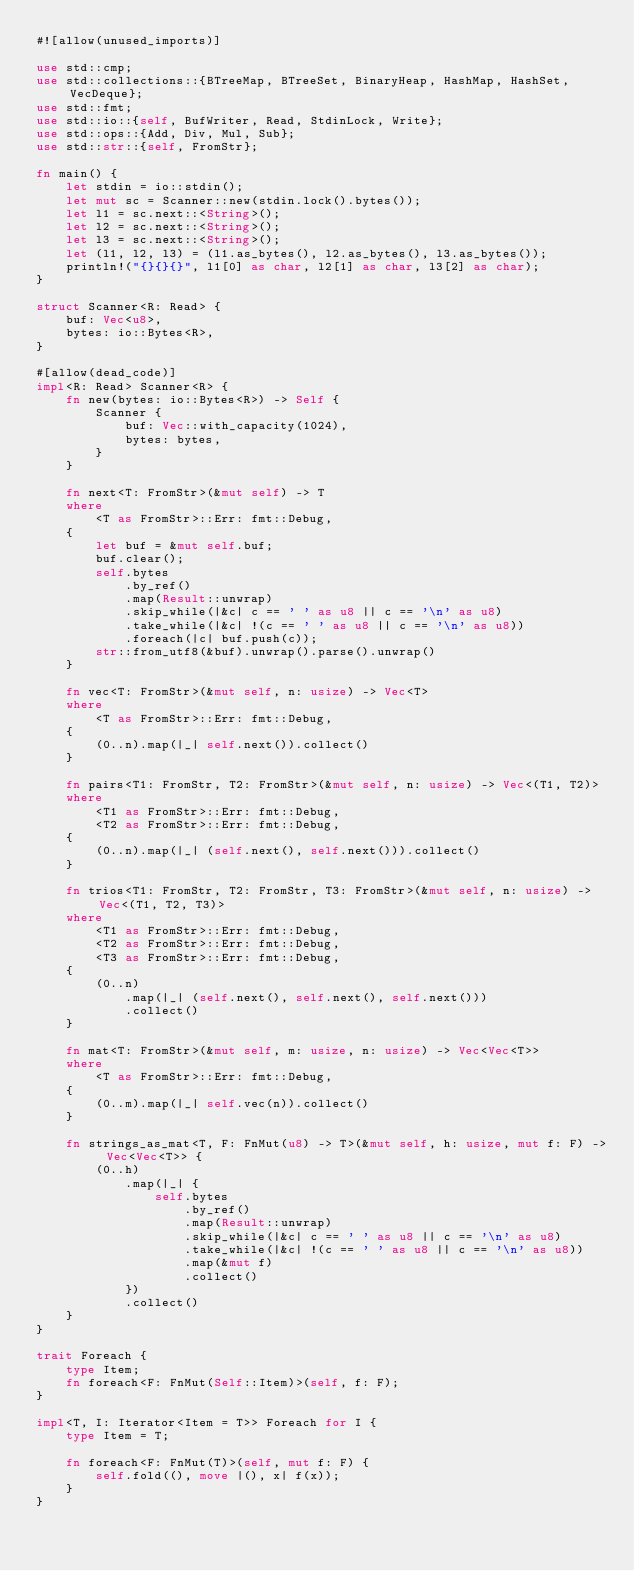Convert code to text. <code><loc_0><loc_0><loc_500><loc_500><_Rust_>#![allow(unused_imports)]

use std::cmp;
use std::collections::{BTreeMap, BTreeSet, BinaryHeap, HashMap, HashSet, VecDeque};
use std::fmt;
use std::io::{self, BufWriter, Read, StdinLock, Write};
use std::ops::{Add, Div, Mul, Sub};
use std::str::{self, FromStr};

fn main() {
    let stdin = io::stdin();
    let mut sc = Scanner::new(stdin.lock().bytes());
    let l1 = sc.next::<String>();
    let l2 = sc.next::<String>();
    let l3 = sc.next::<String>();
    let (l1, l2, l3) = (l1.as_bytes(), l2.as_bytes(), l3.as_bytes());
    println!("{}{}{}", l1[0] as char, l2[1] as char, l3[2] as char);
}

struct Scanner<R: Read> {
    buf: Vec<u8>,
    bytes: io::Bytes<R>,
}

#[allow(dead_code)]
impl<R: Read> Scanner<R> {
    fn new(bytes: io::Bytes<R>) -> Self {
        Scanner {
            buf: Vec::with_capacity(1024),
            bytes: bytes,
        }
    }

    fn next<T: FromStr>(&mut self) -> T
    where
        <T as FromStr>::Err: fmt::Debug,
    {
        let buf = &mut self.buf;
        buf.clear();
        self.bytes
            .by_ref()
            .map(Result::unwrap)
            .skip_while(|&c| c == ' ' as u8 || c == '\n' as u8)
            .take_while(|&c| !(c == ' ' as u8 || c == '\n' as u8))
            .foreach(|c| buf.push(c));
        str::from_utf8(&buf).unwrap().parse().unwrap()
    }

    fn vec<T: FromStr>(&mut self, n: usize) -> Vec<T>
    where
        <T as FromStr>::Err: fmt::Debug,
    {
        (0..n).map(|_| self.next()).collect()
    }

    fn pairs<T1: FromStr, T2: FromStr>(&mut self, n: usize) -> Vec<(T1, T2)>
    where
        <T1 as FromStr>::Err: fmt::Debug,
        <T2 as FromStr>::Err: fmt::Debug,
    {
        (0..n).map(|_| (self.next(), self.next())).collect()
    }

    fn trios<T1: FromStr, T2: FromStr, T3: FromStr>(&mut self, n: usize) -> Vec<(T1, T2, T3)>
    where
        <T1 as FromStr>::Err: fmt::Debug,
        <T2 as FromStr>::Err: fmt::Debug,
        <T3 as FromStr>::Err: fmt::Debug,
    {
        (0..n)
            .map(|_| (self.next(), self.next(), self.next()))
            .collect()
    }

    fn mat<T: FromStr>(&mut self, m: usize, n: usize) -> Vec<Vec<T>>
    where
        <T as FromStr>::Err: fmt::Debug,
    {
        (0..m).map(|_| self.vec(n)).collect()
    }

    fn strings_as_mat<T, F: FnMut(u8) -> T>(&mut self, h: usize, mut f: F) -> Vec<Vec<T>> {
        (0..h)
            .map(|_| {
                self.bytes
                    .by_ref()
                    .map(Result::unwrap)
                    .skip_while(|&c| c == ' ' as u8 || c == '\n' as u8)
                    .take_while(|&c| !(c == ' ' as u8 || c == '\n' as u8))
                    .map(&mut f)
                    .collect()
            })
            .collect()
    }
}

trait Foreach {
    type Item;
    fn foreach<F: FnMut(Self::Item)>(self, f: F);
}

impl<T, I: Iterator<Item = T>> Foreach for I {
    type Item = T;

    fn foreach<F: FnMut(T)>(self, mut f: F) {
        self.fold((), move |(), x| f(x));
    }
}
</code> 